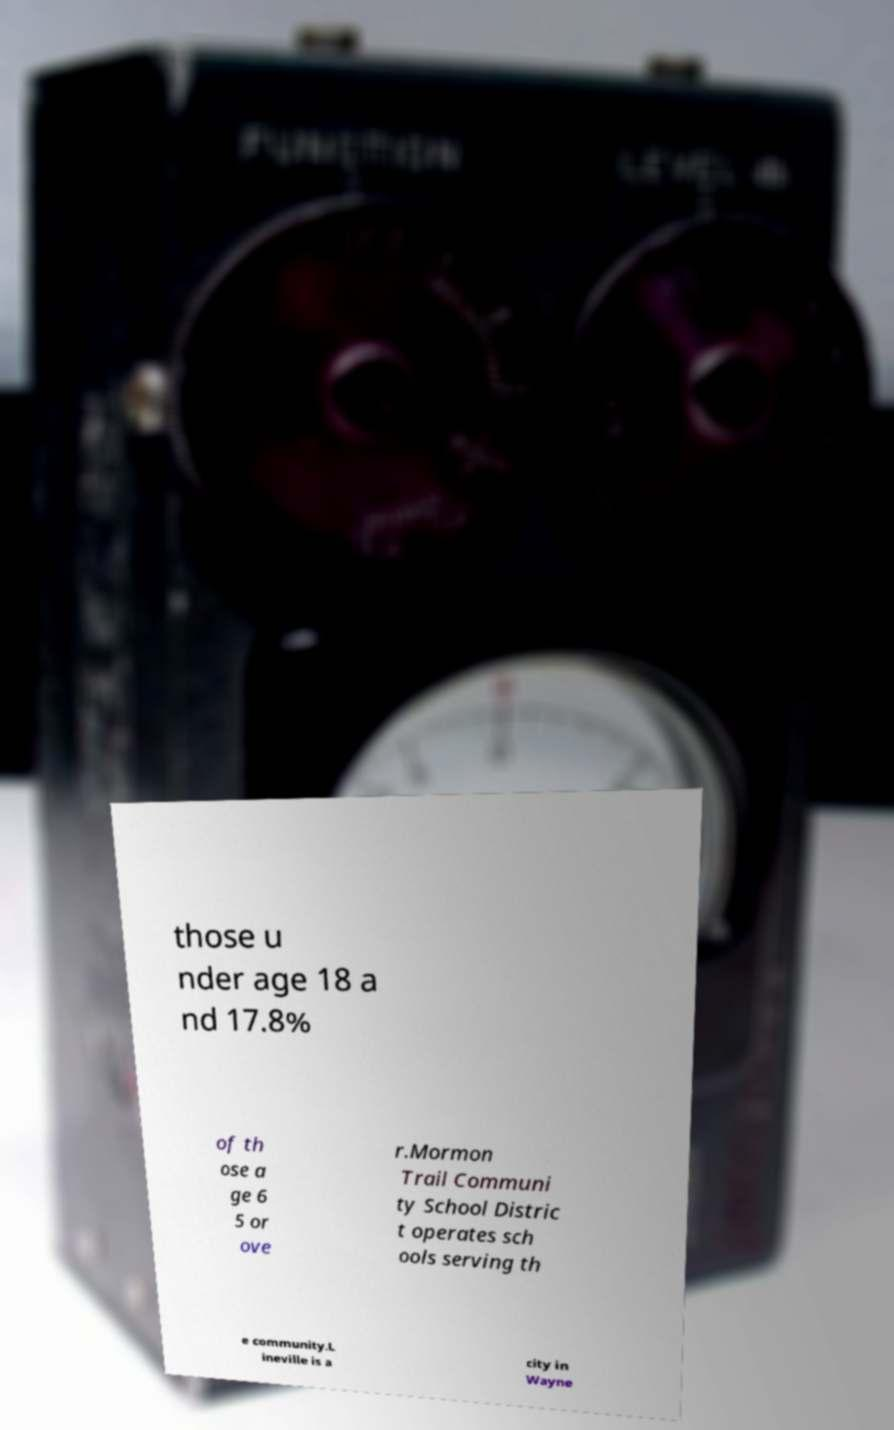Could you extract and type out the text from this image? those u nder age 18 a nd 17.8% of th ose a ge 6 5 or ove r.Mormon Trail Communi ty School Distric t operates sch ools serving th e community.L ineville is a city in Wayne 